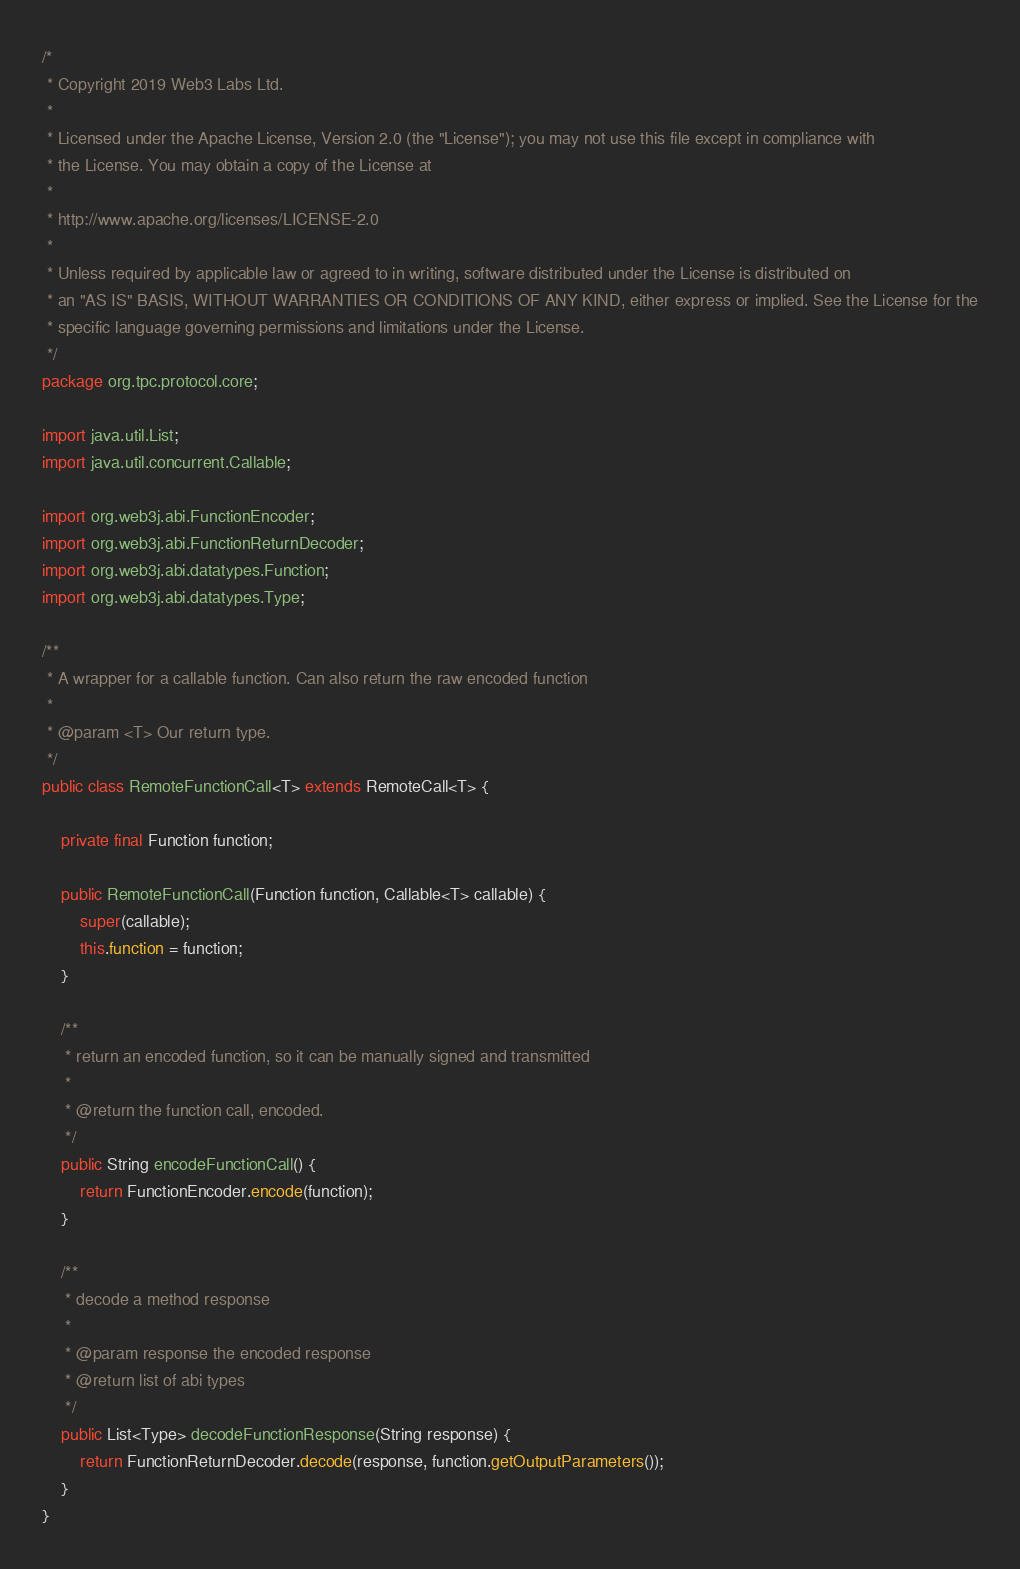Convert code to text. <code><loc_0><loc_0><loc_500><loc_500><_Java_>/*
 * Copyright 2019 Web3 Labs Ltd.
 *
 * Licensed under the Apache License, Version 2.0 (the "License"); you may not use this file except in compliance with
 * the License. You may obtain a copy of the License at
 *
 * http://www.apache.org/licenses/LICENSE-2.0
 *
 * Unless required by applicable law or agreed to in writing, software distributed under the License is distributed on
 * an "AS IS" BASIS, WITHOUT WARRANTIES OR CONDITIONS OF ANY KIND, either express or implied. See the License for the
 * specific language governing permissions and limitations under the License.
 */
package org.tpc.protocol.core;

import java.util.List;
import java.util.concurrent.Callable;

import org.web3j.abi.FunctionEncoder;
import org.web3j.abi.FunctionReturnDecoder;
import org.web3j.abi.datatypes.Function;
import org.web3j.abi.datatypes.Type;

/**
 * A wrapper for a callable function. Can also return the raw encoded function
 *
 * @param <T> Our return type.
 */
public class RemoteFunctionCall<T> extends RemoteCall<T> {

    private final Function function;

    public RemoteFunctionCall(Function function, Callable<T> callable) {
        super(callable);
        this.function = function;
    }

    /**
     * return an encoded function, so it can be manually signed and transmitted
     *
     * @return the function call, encoded.
     */
    public String encodeFunctionCall() {
        return FunctionEncoder.encode(function);
    }

    /**
     * decode a method response
     *
     * @param response the encoded response
     * @return list of abi types
     */
    public List<Type> decodeFunctionResponse(String response) {
        return FunctionReturnDecoder.decode(response, function.getOutputParameters());
    }
}
</code> 